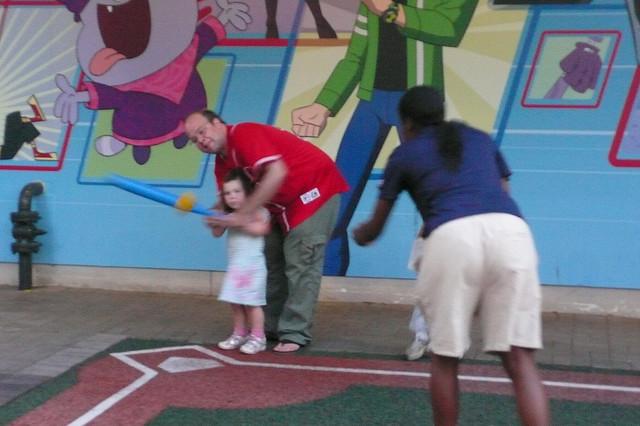What is the girl playing?
Keep it brief. Baseball. What is the child holding?
Keep it brief. Bat. What color is the bat?
Concise answer only. Blue. What is the child doing?
Answer briefly. Baseball. What is the lady on the side doing?
Answer briefly. Pitching. Who is this a picture of?
Keep it brief. Girl. What is the girl learning how to do?
Keep it brief. Bat. What shape is painted on the floor?
Give a very brief answer. Baseball field. Can you see the pitcher?
Write a very short answer. Yes. What sport are they participating in?
Answer briefly. Baseball. 